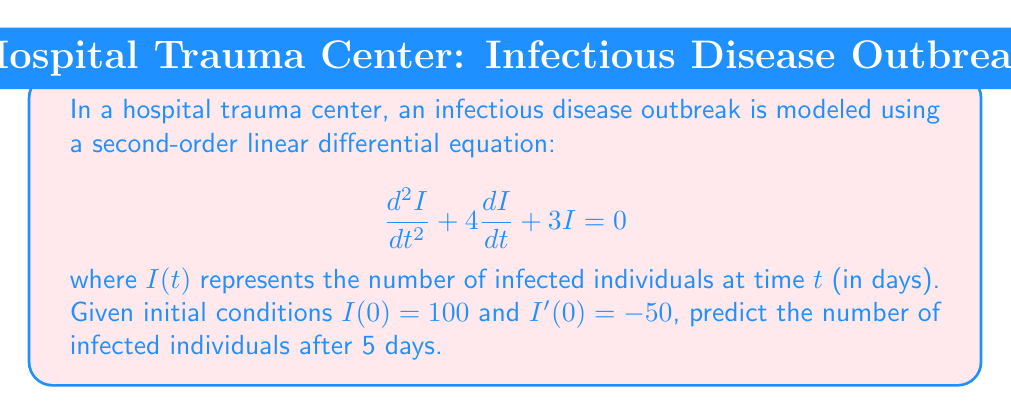Show me your answer to this math problem. 1) The general solution for this second-order linear differential equation is:
   $$I(t) = c_1e^{-t} + c_2e^{-3t}$$

2) We need to find $c_1$ and $c_2$ using the initial conditions:
   $I(0) = 100$ and $I'(0) = -50$

3) Using $I(0) = 100$:
   $$100 = c_1 + c_2$$

4) Taking the derivative of $I(t)$:
   $$I'(t) = -c_1e^{-t} - 3c_2e^{-3t}$$

5) Using $I'(0) = -50$:
   $$-50 = -c_1 - 3c_2$$

6) Solving the system of equations:
   $$c_1 + c_2 = 100$$
   $$c_1 + 3c_2 = 50$$

   Subtracting the second equation from the first:
   $$-2c_2 = 50$$
   $$c_2 = -25$$

   Substituting back:
   $$c_1 = 125$$

7) The particular solution is:
   $$I(t) = 125e^{-t} - 25e^{-3t}$$

8) To find $I(5)$, we substitute $t=5$:
   $$I(5) = 125e^{-5} - 25e^{-15}$$

9) Evaluating:
   $$I(5) \approx 0.8422 - 0.0000 \approx 0.8422$$
Answer: $0.8422$ infected individuals (rounded to 4 decimal places) 